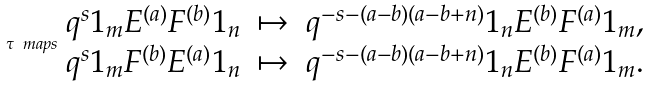<formula> <loc_0><loc_0><loc_500><loc_500>\tau \ m a p s \begin{array} { c c c } q ^ { s } 1 _ { m } E ^ { ( a ) } F ^ { ( b ) } 1 _ { n } & \mapsto & q ^ { - s - ( a - b ) ( a - b + n ) } 1 _ { n } E ^ { ( b ) } F ^ { ( a ) } 1 _ { m } , \\ q ^ { s } 1 _ { m } F ^ { ( b ) } E ^ { ( a ) } 1 _ { n } & \mapsto & q ^ { - s - ( a - b ) ( a - b + n ) } 1 _ { n } E ^ { ( b ) } F ^ { ( a ) } 1 _ { m } . \end{array}</formula> 